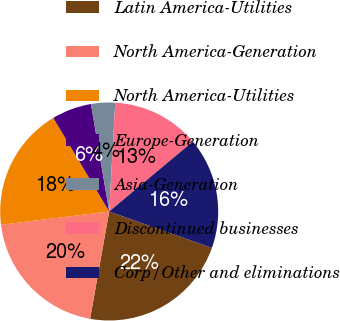<chart> <loc_0><loc_0><loc_500><loc_500><pie_chart><fcel>Latin America-Utilities<fcel>North America-Generation<fcel>North America-Utilities<fcel>Europe-Generation<fcel>Asia-Generation<fcel>Discontinued businesses<fcel>Corp/Other and eliminations<nl><fcel>22.39%<fcel>20.25%<fcel>18.37%<fcel>5.9%<fcel>3.56%<fcel>13.03%<fcel>16.49%<nl></chart> 